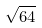<formula> <loc_0><loc_0><loc_500><loc_500>\sqrt { 6 4 }</formula> 